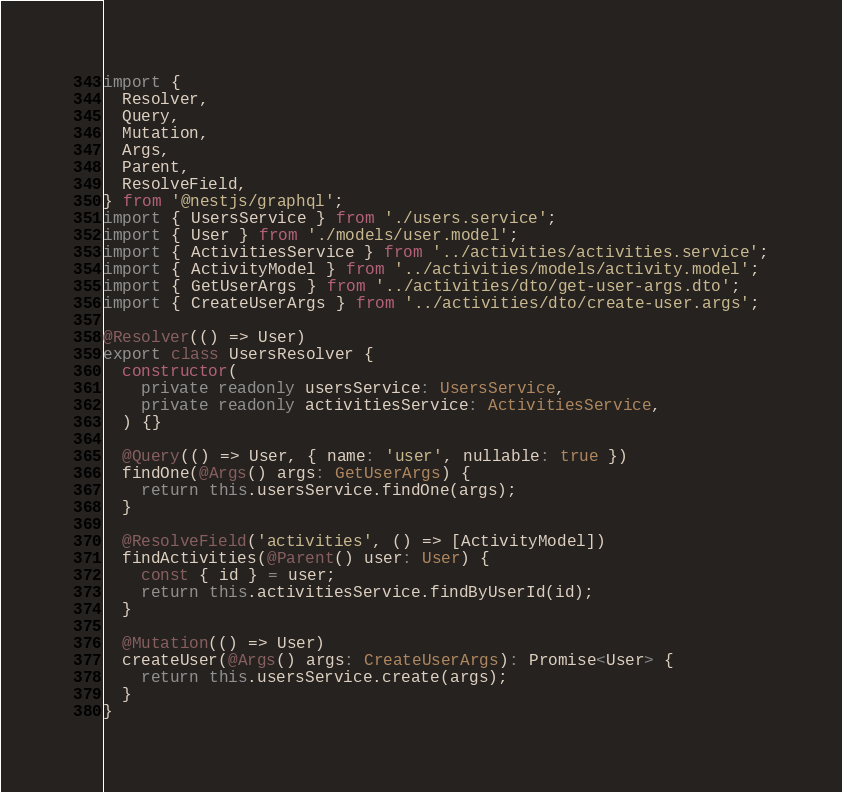Convert code to text. <code><loc_0><loc_0><loc_500><loc_500><_TypeScript_>import {
  Resolver,
  Query,
  Mutation,
  Args,
  Parent,
  ResolveField,
} from '@nestjs/graphql';
import { UsersService } from './users.service';
import { User } from './models/user.model';
import { ActivitiesService } from '../activities/activities.service';
import { ActivityModel } from '../activities/models/activity.model';
import { GetUserArgs } from '../activities/dto/get-user-args.dto';
import { CreateUserArgs } from '../activities/dto/create-user.args';

@Resolver(() => User)
export class UsersResolver {
  constructor(
    private readonly usersService: UsersService,
    private readonly activitiesService: ActivitiesService,
  ) {}

  @Query(() => User, { name: 'user', nullable: true })
  findOne(@Args() args: GetUserArgs) {
    return this.usersService.findOne(args);
  }

  @ResolveField('activities', () => [ActivityModel])
  findActivities(@Parent() user: User) {
    const { id } = user;
    return this.activitiesService.findByUserId(id);
  }

  @Mutation(() => User)
  createUser(@Args() args: CreateUserArgs): Promise<User> {
    return this.usersService.create(args);
  }
}
</code> 